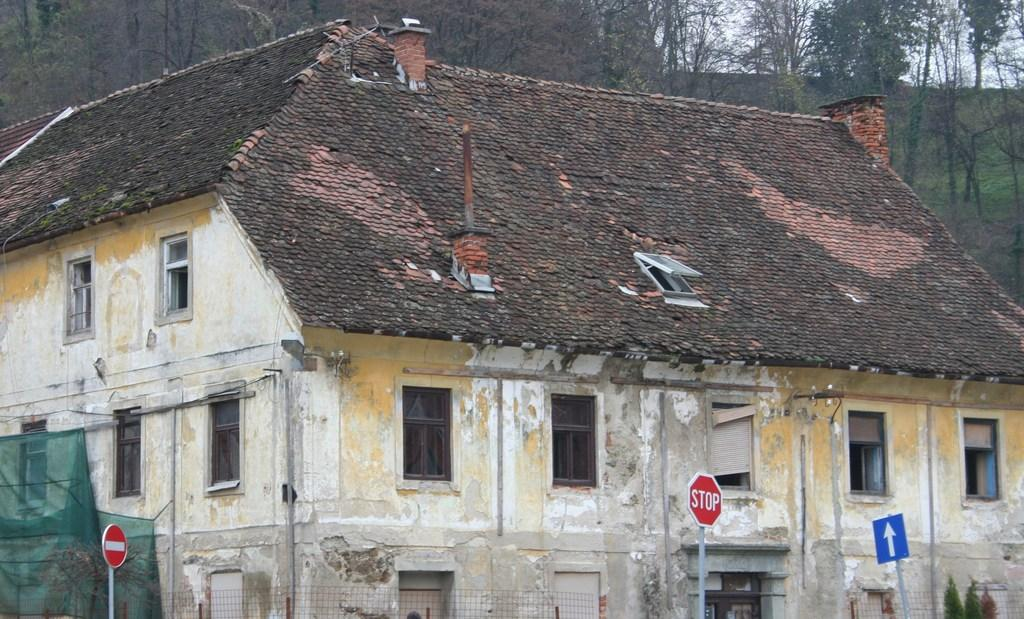What type of structure is present in the image? There is a building in the image. What objects can be seen in front of the building? There are boards in the image. What can be seen in the distance behind the building? There are trees in the background of the image. What is visible above the trees and building in the image? The sky is visible in the background of the image. How many babies are playing with shoes in the image? There are no babies or shoes present in the image. What type of transport is visible in the image? There is no transport visible in the image; it only features a building, boards, trees, and the sky. 